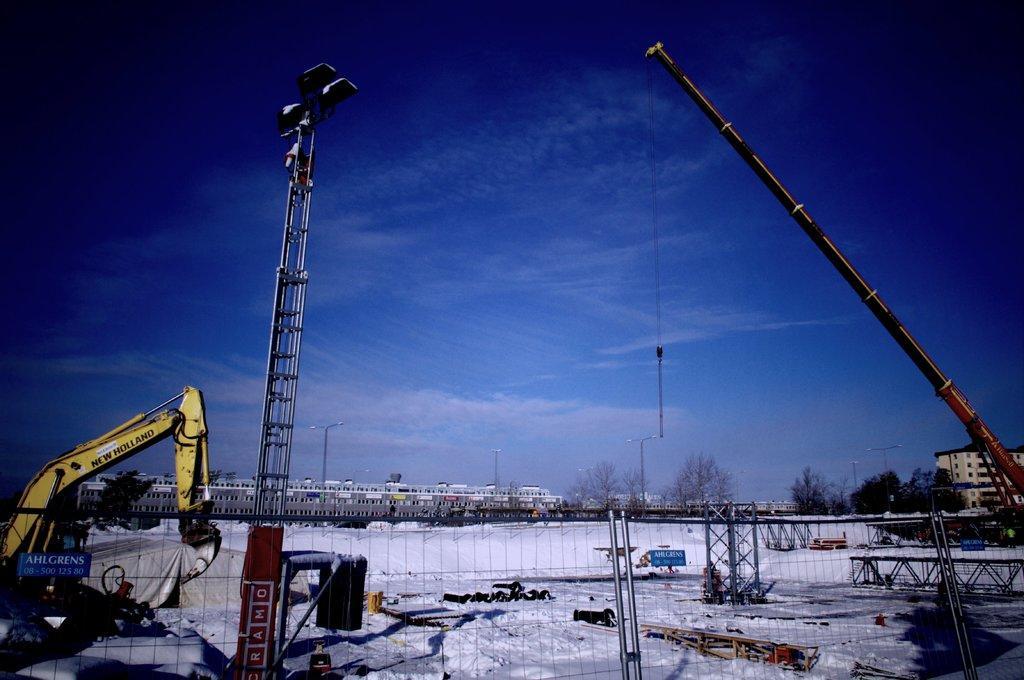Could you give a brief overview of what you see in this image? In the picture I can see vehicles, trees, fence, poles, street lights, buildings and some other objects. In the background I can see the sky. 